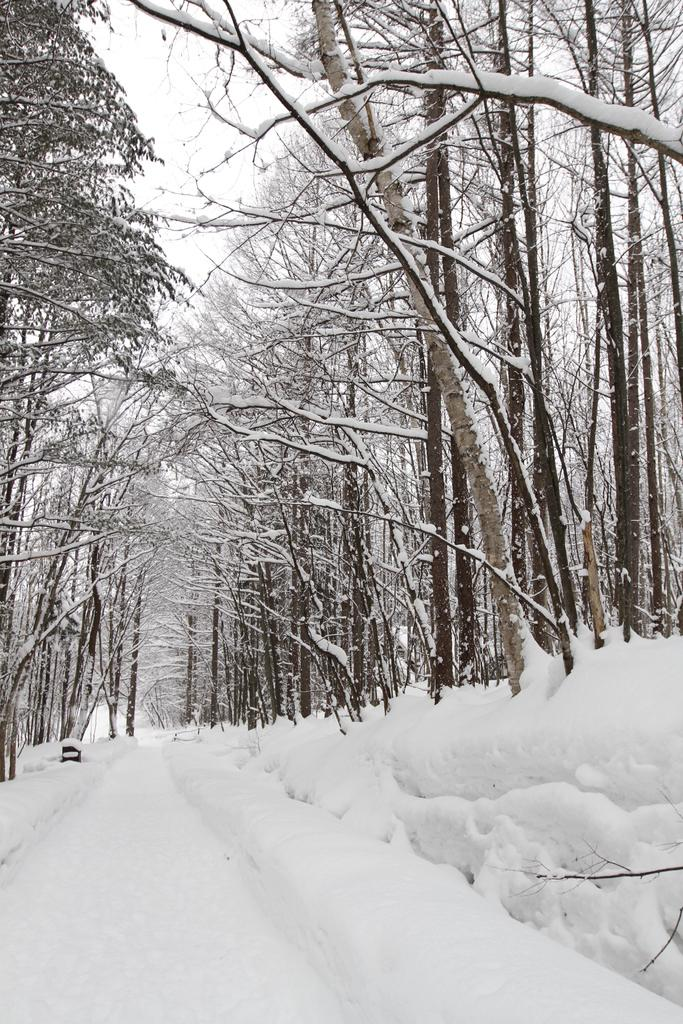What type of vegetation is present in the image? There are trees in the image. How are the trees in the image affected by the weather? The trees are covered with snow. What is the ground condition in the image? There is snow at the bottom of the image. How many knees are visible in the image? There are no knees present in the image; it features trees covered with snow and snow on the ground. 